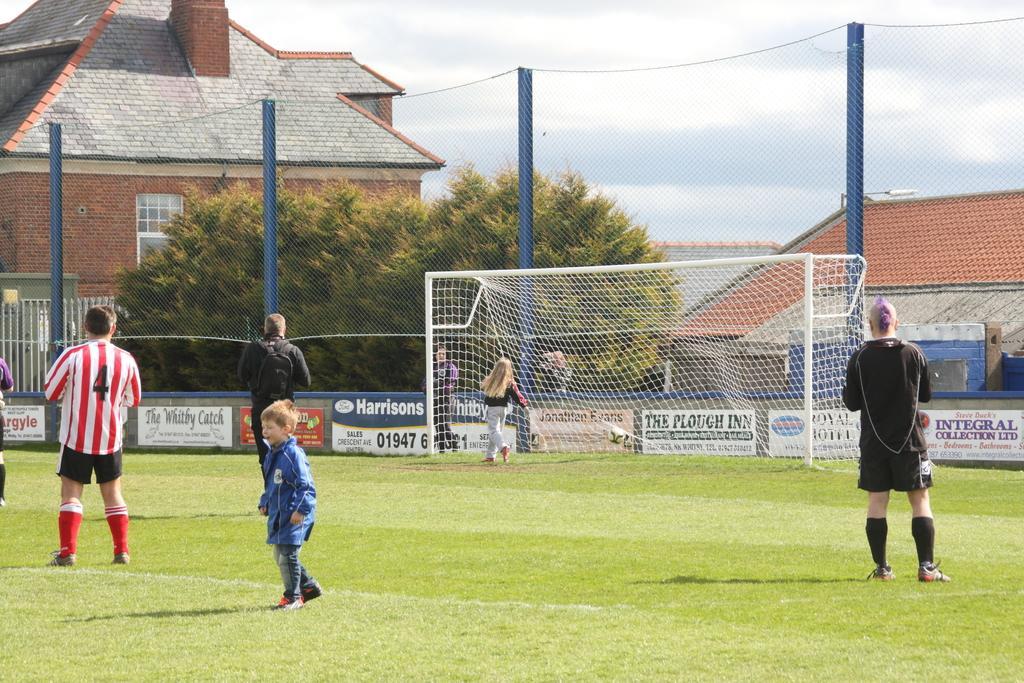Please provide a concise description of this image. In this image we can see there are people standing on the ground and there is a football net and football. At the back we can see the wall with text. And there are trees, buildings, fence and sky in the background. 